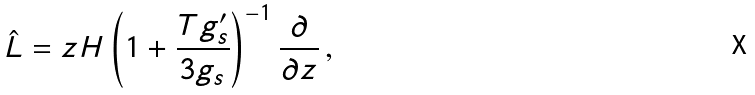<formula> <loc_0><loc_0><loc_500><loc_500>\hat { L } = z H \left ( 1 + \frac { T g ^ { \prime } _ { s } } { 3 g _ { s } } \right ) ^ { - 1 } \frac { \partial } { \partial z } \, ,</formula> 